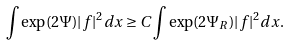Convert formula to latex. <formula><loc_0><loc_0><loc_500><loc_500>\int \exp ( 2 \Psi ) | f | ^ { 2 } d x \geq C \int \exp ( 2 \Psi _ { R } ) | f | ^ { 2 } d x .</formula> 